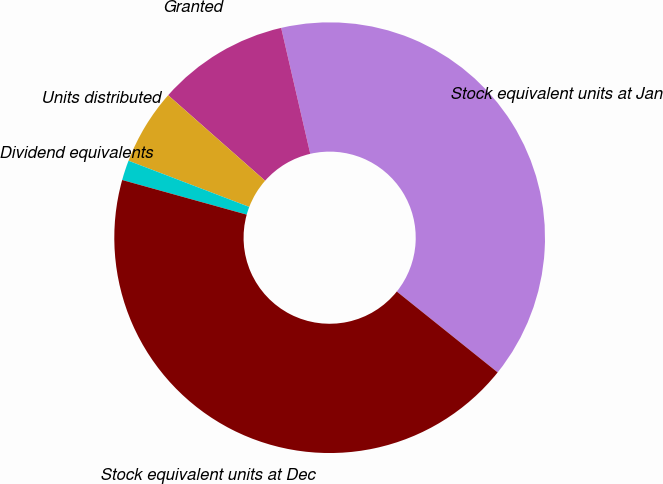Convert chart to OTSL. <chart><loc_0><loc_0><loc_500><loc_500><pie_chart><fcel>Stock equivalent units at Jan<fcel>Granted<fcel>Units distributed<fcel>Dividend equivalents<fcel>Stock equivalent units at Dec<nl><fcel>39.37%<fcel>9.88%<fcel>5.69%<fcel>1.5%<fcel>43.56%<nl></chart> 